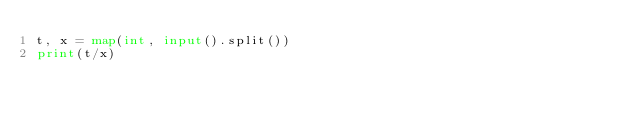<code> <loc_0><loc_0><loc_500><loc_500><_Python_>t, x = map(int, input().split())
print(t/x)</code> 